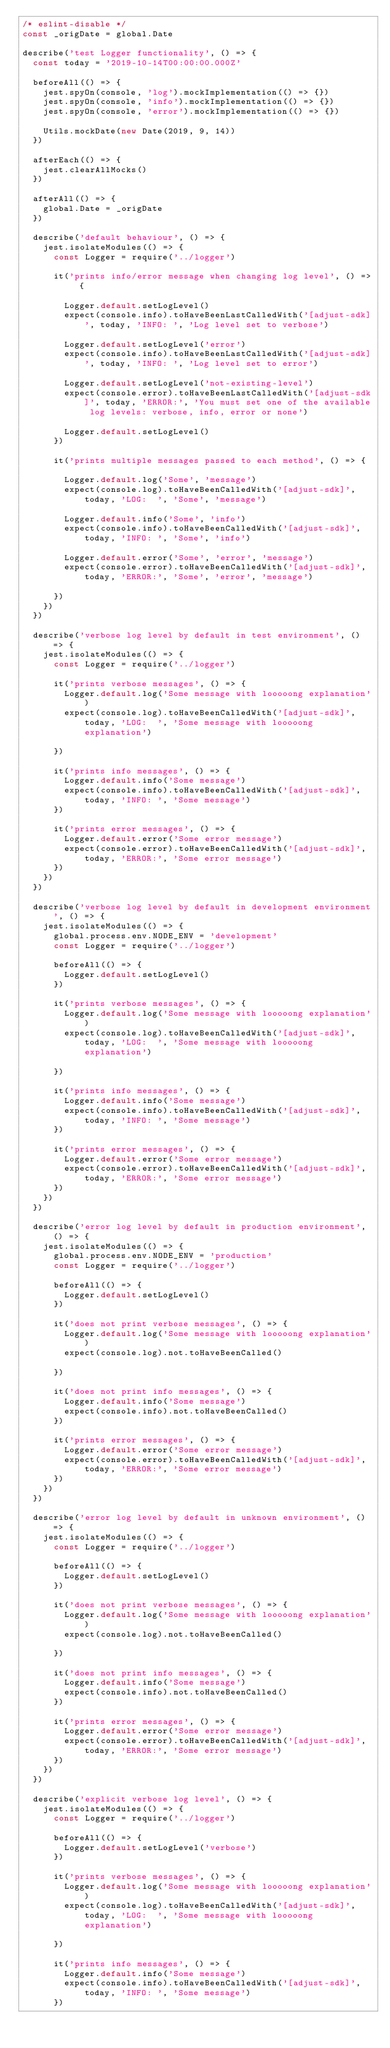Convert code to text. <code><loc_0><loc_0><loc_500><loc_500><_JavaScript_>/* eslint-disable */
const _origDate = global.Date

describe('test Logger functionality', () => {
  const today = '2019-10-14T00:00:00.000Z'

  beforeAll(() => {
    jest.spyOn(console, 'log').mockImplementation(() => {})
    jest.spyOn(console, 'info').mockImplementation(() => {})
    jest.spyOn(console, 'error').mockImplementation(() => {})

    Utils.mockDate(new Date(2019, 9, 14))
  })

  afterEach(() => {
    jest.clearAllMocks()
  })

  afterAll(() => {
    global.Date = _origDate
  })

  describe('default behaviour', () => {
    jest.isolateModules(() => {
      const Logger = require('../logger')

      it('prints info/error message when changing log level', () => {

        Logger.default.setLogLevel()
        expect(console.info).toHaveBeenLastCalledWith('[adjust-sdk]', today, 'INFO: ', 'Log level set to verbose')

        Logger.default.setLogLevel('error')
        expect(console.info).toHaveBeenLastCalledWith('[adjust-sdk]', today, 'INFO: ', 'Log level set to error')

        Logger.default.setLogLevel('not-existing-level')
        expect(console.error).toHaveBeenLastCalledWith('[adjust-sdk]', today, 'ERROR:', 'You must set one of the available log levels: verbose, info, error or none')

        Logger.default.setLogLevel()
      })

      it('prints multiple messages passed to each method', () => {

        Logger.default.log('Some', 'message')
        expect(console.log).toHaveBeenCalledWith('[adjust-sdk]', today, 'LOG:  ', 'Some', 'message')

        Logger.default.info('Some', 'info')
        expect(console.info).toHaveBeenCalledWith('[adjust-sdk]', today, 'INFO: ', 'Some', 'info')

        Logger.default.error('Some', 'error', 'message')
        expect(console.error).toHaveBeenCalledWith('[adjust-sdk]', today, 'ERROR:', 'Some', 'error', 'message')

      })
    })
  })

  describe('verbose log level by default in test environment', () => {
    jest.isolateModules(() => {
      const Logger = require('../logger')

      it('prints verbose messages', () => {
        Logger.default.log('Some message with looooong explanation')
        expect(console.log).toHaveBeenCalledWith('[adjust-sdk]', today, 'LOG:  ', 'Some message with looooong explanation')

      })

      it('prints info messages', () => {
        Logger.default.info('Some message')
        expect(console.info).toHaveBeenCalledWith('[adjust-sdk]', today, 'INFO: ', 'Some message')
      })

      it('prints error messages', () => {
        Logger.default.error('Some error message')
        expect(console.error).toHaveBeenCalledWith('[adjust-sdk]', today, 'ERROR:', 'Some error message')
      })
    })
  })

  describe('verbose log level by default in development environment', () => {
    jest.isolateModules(() => {
      global.process.env.NODE_ENV = 'development'
      const Logger = require('../logger')

      beforeAll(() => {
        Logger.default.setLogLevel()
      })

      it('prints verbose messages', () => {
        Logger.default.log('Some message with looooong explanation')
        expect(console.log).toHaveBeenCalledWith('[adjust-sdk]', today, 'LOG:  ', 'Some message with looooong explanation')

      })

      it('prints info messages', () => {
        Logger.default.info('Some message')
        expect(console.info).toHaveBeenCalledWith('[adjust-sdk]', today, 'INFO: ', 'Some message')
      })

      it('prints error messages', () => {
        Logger.default.error('Some error message')
        expect(console.error).toHaveBeenCalledWith('[adjust-sdk]', today, 'ERROR:', 'Some error message')
      })
    })
  })

  describe('error log level by default in production environment', () => {
    jest.isolateModules(() => {
      global.process.env.NODE_ENV = 'production'
      const Logger = require('../logger')

      beforeAll(() => {
        Logger.default.setLogLevel()
      })

      it('does not print verbose messages', () => {
        Logger.default.log('Some message with looooong explanation')
        expect(console.log).not.toHaveBeenCalled()

      })

      it('does not print info messages', () => {
        Logger.default.info('Some message')
        expect(console.info).not.toHaveBeenCalled()
      })

      it('prints error messages', () => {
        Logger.default.error('Some error message')
        expect(console.error).toHaveBeenCalledWith('[adjust-sdk]', today, 'ERROR:', 'Some error message')
      })
    })
  })

  describe('error log level by default in unknown environment', () => {
    jest.isolateModules(() => {
      const Logger = require('../logger')

      beforeAll(() => {
        Logger.default.setLogLevel()
      })

      it('does not print verbose messages', () => {
        Logger.default.log('Some message with looooong explanation')
        expect(console.log).not.toHaveBeenCalled()

      })

      it('does not print info messages', () => {
        Logger.default.info('Some message')
        expect(console.info).not.toHaveBeenCalled()
      })

      it('prints error messages', () => {
        Logger.default.error('Some error message')
        expect(console.error).toHaveBeenCalledWith('[adjust-sdk]', today, 'ERROR:', 'Some error message')
      })
    })
  })

  describe('explicit verbose log level', () => {
    jest.isolateModules(() => {
      const Logger = require('../logger')

      beforeAll(() => {
        Logger.default.setLogLevel('verbose')
      })

      it('prints verbose messages', () => {
        Logger.default.log('Some message with looooong explanation')
        expect(console.log).toHaveBeenCalledWith('[adjust-sdk]', today, 'LOG:  ', 'Some message with looooong explanation')

      })

      it('prints info messages', () => {
        Logger.default.info('Some message')
        expect(console.info).toHaveBeenCalledWith('[adjust-sdk]', today, 'INFO: ', 'Some message')
      })
</code> 